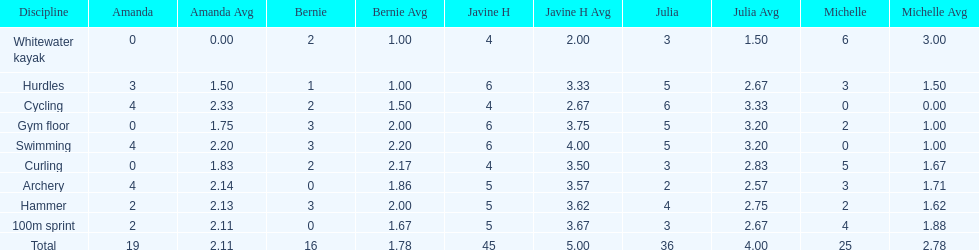What is the average score on 100m sprint? 2.8. 